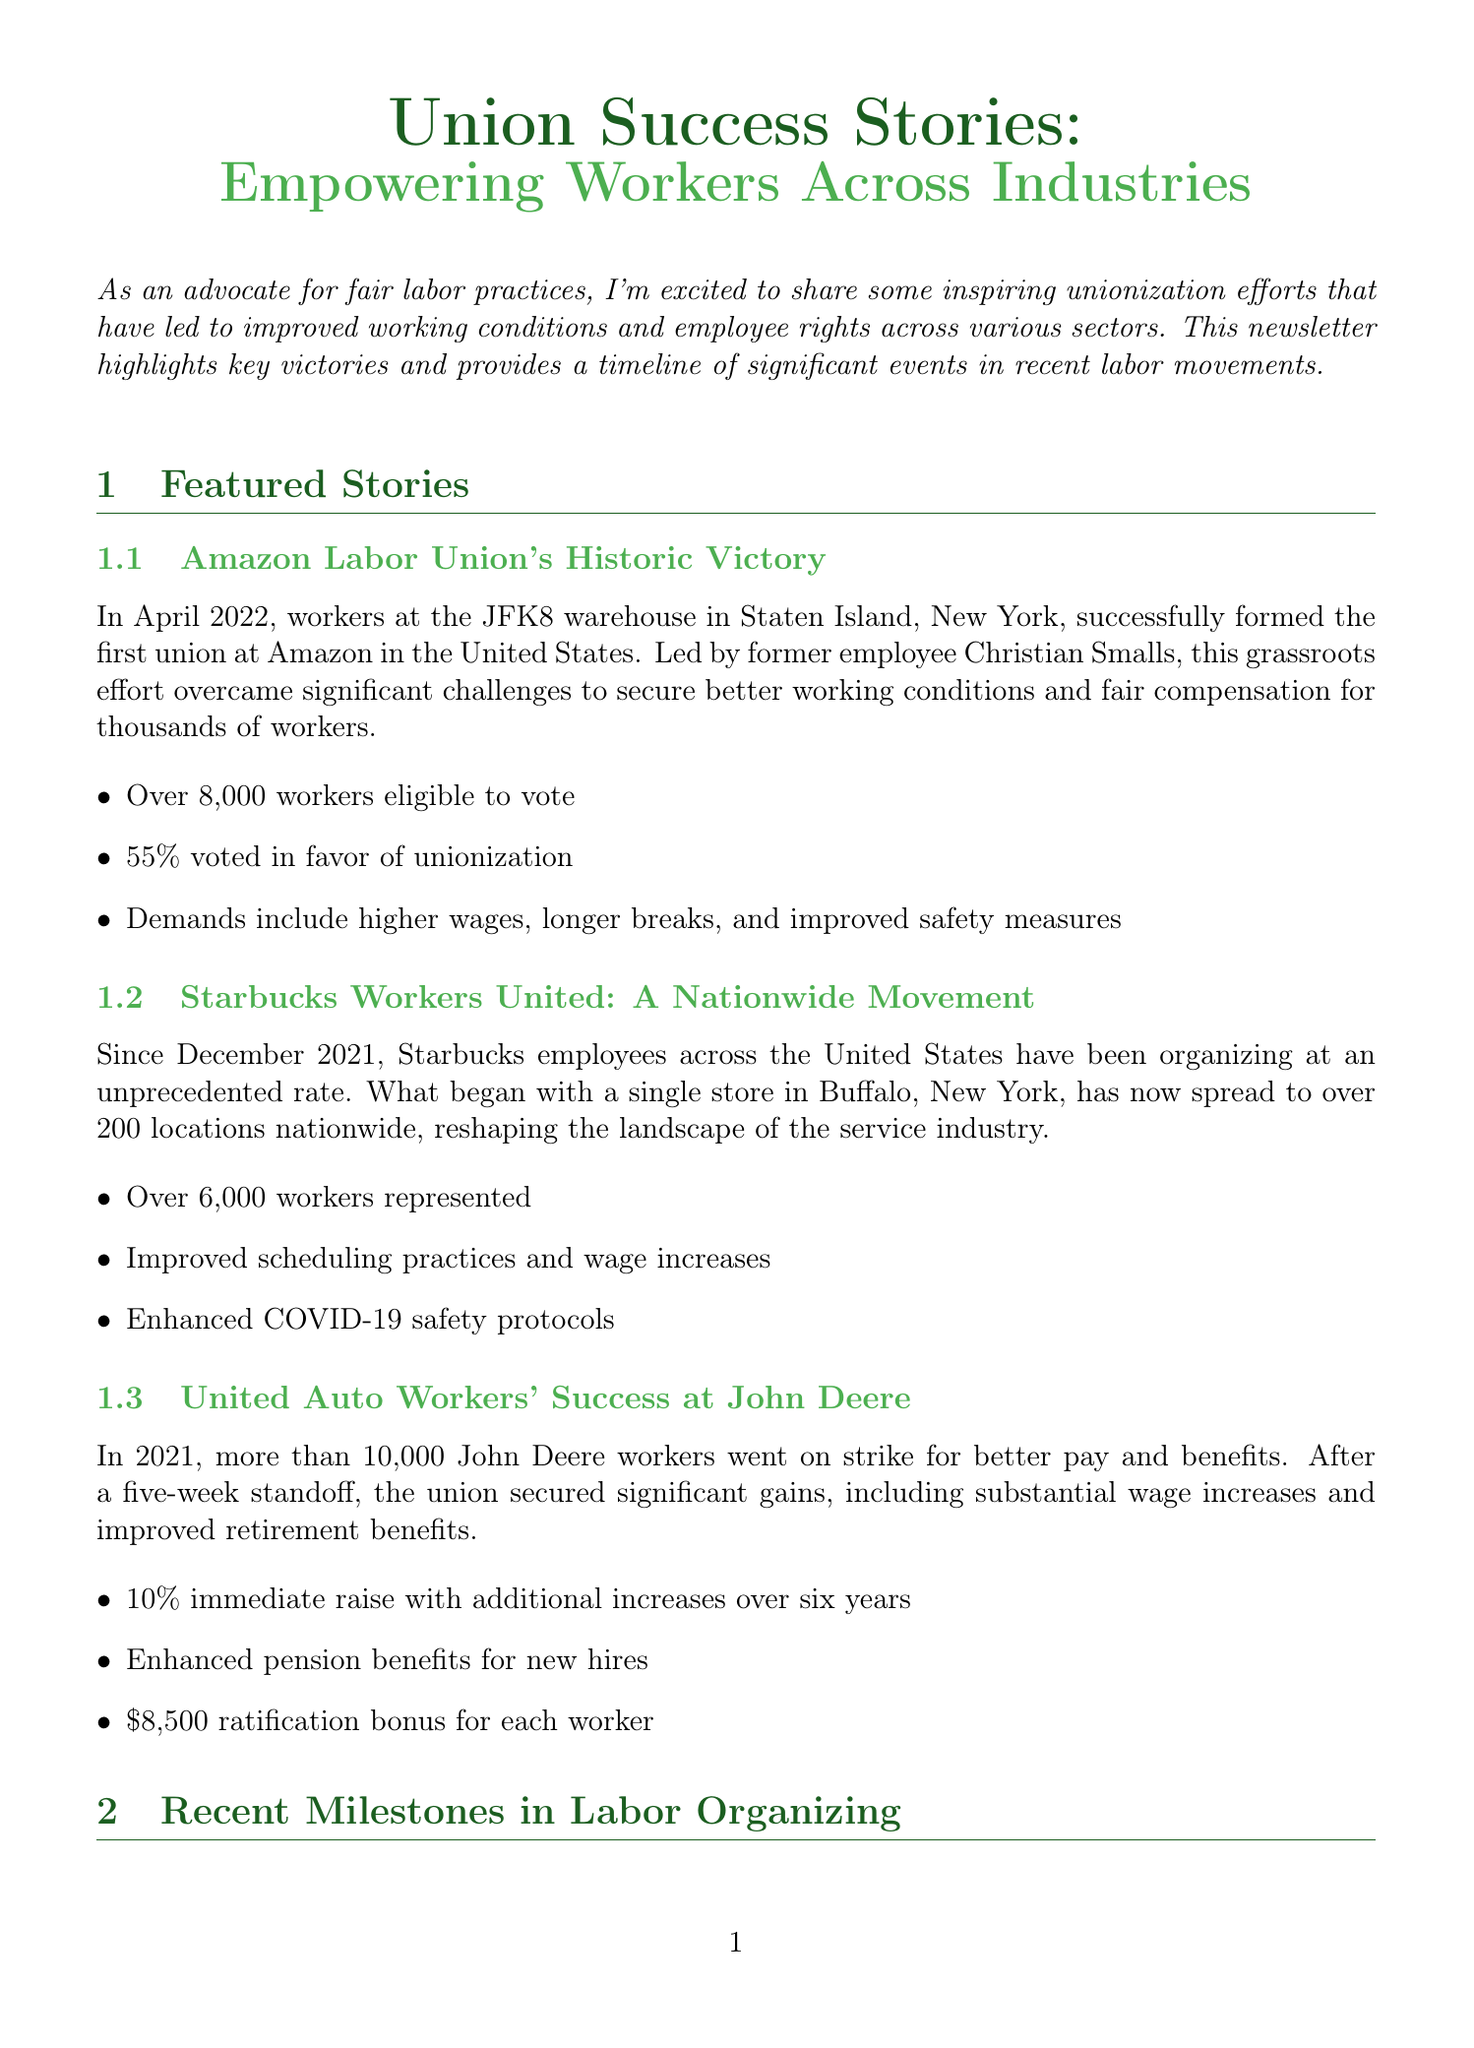What is the title of the newsletter? The title of the newsletter is indicated at the beginning of the document as "Union Success Stories: Empowering Workers Across Industries."
Answer: Union Success Stories: Empowering Workers Across Industries When did the Amazon Labor Union win its election? The document specifies that the Amazon Labor Union won the election in April 2022.
Answer: April 2022 How many workers were represented by Starbucks Workers United? The newsletter mentions that Starbucks Workers United represents over 6,000 workers.
Answer: Over 6,000 workers What significant event occurred in December 2021? According to the timeline, the event is the first Starbucks store unionizing in Buffalo, NY.
Answer: First Starbucks store unionizes in Buffalo, NY How many John Deere workers went on strike in 2021? It states that more than 10,000 John Deere workers went on strike for better pay and benefits.
Answer: More than 10,000 What was a key demand for the Amazon Labor Union? The document lists demands including higher wages, longer breaks, and improved safety measures.
Answer: Higher wages Which resource offers a guide to starting a union? The Union Organizing Toolkit is mentioned as the resource that provides a step-by-step guide for starting a union in the workplace.
Answer: Union Organizing Toolkit What is the call to action in the newsletter? The call to action encourages readers to join a monthly webinar series on emerging trends in labor organizing and workplace rights.
Answer: Join our monthly webinar series What are the notable improvements achieved by the UAW at John Deere? The document highlights significant gains such as a 10% immediate raise and enhanced pension benefits for new hires.
Answer: 10% immediate raise 